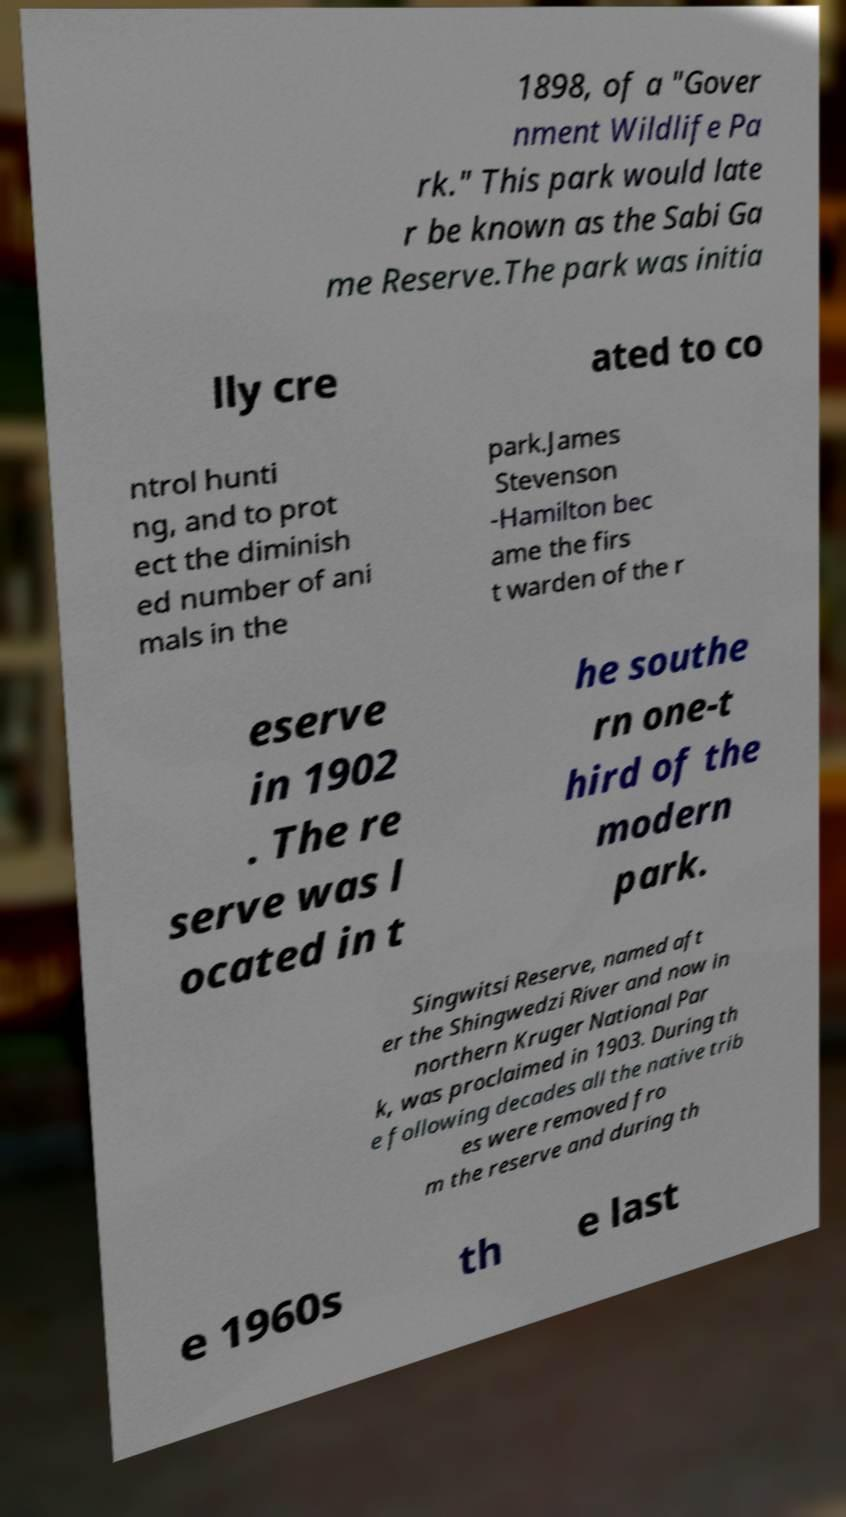Please read and relay the text visible in this image. What does it say? 1898, of a "Gover nment Wildlife Pa rk." This park would late r be known as the Sabi Ga me Reserve.The park was initia lly cre ated to co ntrol hunti ng, and to prot ect the diminish ed number of ani mals in the park.James Stevenson -Hamilton bec ame the firs t warden of the r eserve in 1902 . The re serve was l ocated in t he southe rn one-t hird of the modern park. Singwitsi Reserve, named aft er the Shingwedzi River and now in northern Kruger National Par k, was proclaimed in 1903. During th e following decades all the native trib es were removed fro m the reserve and during th e 1960s th e last 